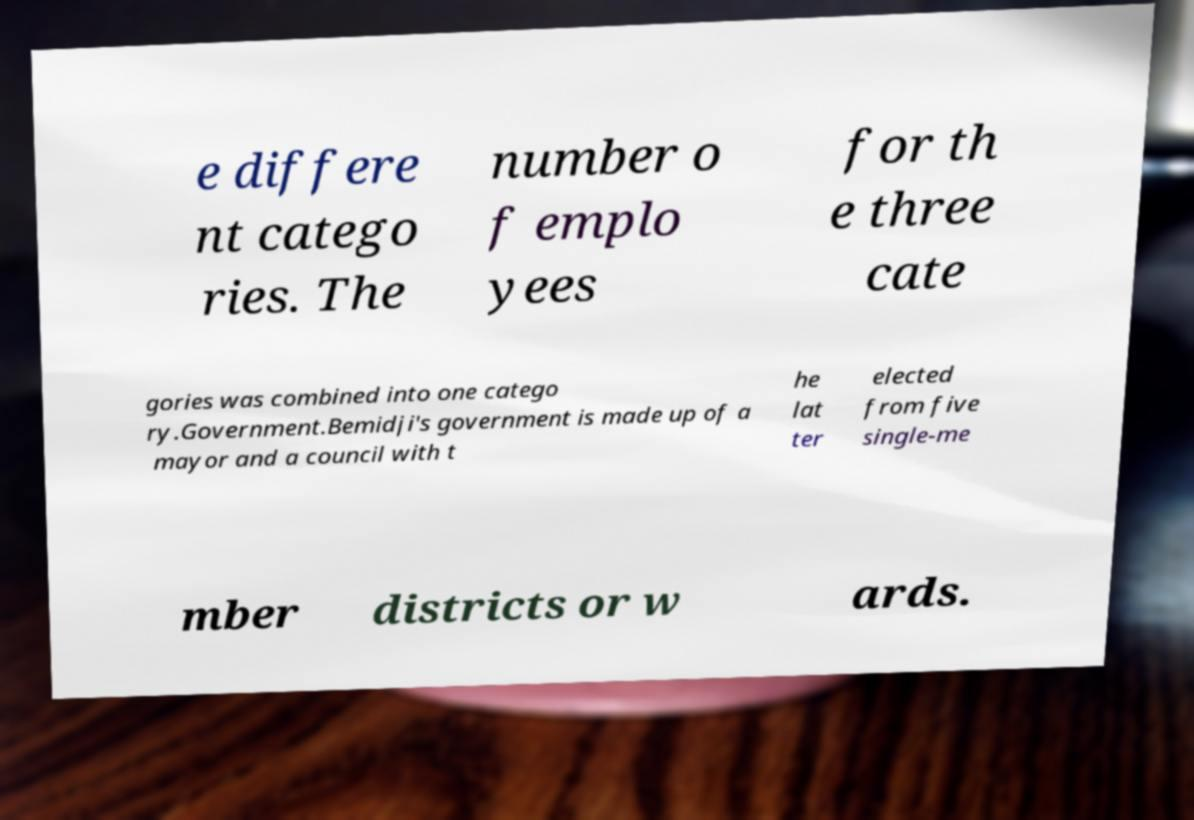I need the written content from this picture converted into text. Can you do that? e differe nt catego ries. The number o f emplo yees for th e three cate gories was combined into one catego ry.Government.Bemidji's government is made up of a mayor and a council with t he lat ter elected from five single-me mber districts or w ards. 